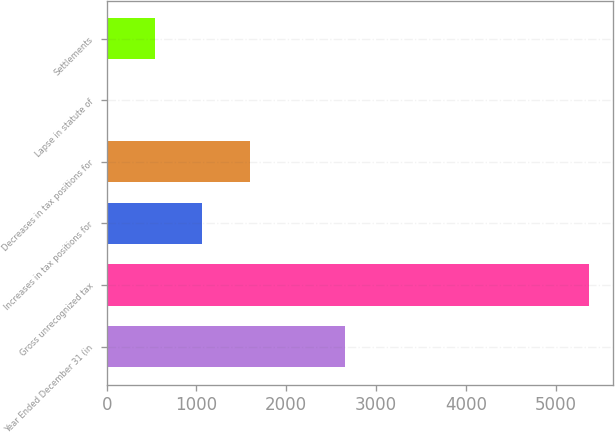Convert chart to OTSL. <chart><loc_0><loc_0><loc_500><loc_500><bar_chart><fcel>Year Ended December 31 (in<fcel>Gross unrecognized tax<fcel>Increases in tax positions for<fcel>Decreases in tax positions for<fcel>Lapse in statute of<fcel>Settlements<nl><fcel>2651<fcel>5372<fcel>1064<fcel>1593<fcel>6<fcel>535<nl></chart> 